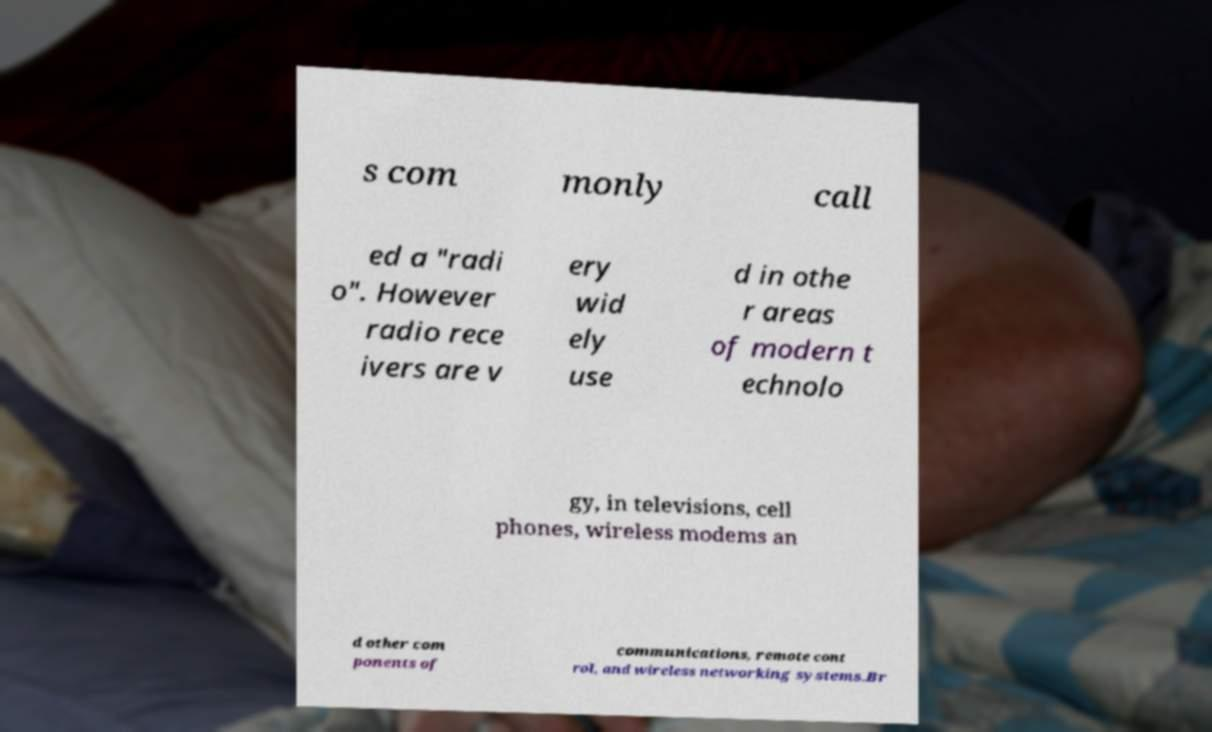Could you assist in decoding the text presented in this image and type it out clearly? s com monly call ed a "radi o". However radio rece ivers are v ery wid ely use d in othe r areas of modern t echnolo gy, in televisions, cell phones, wireless modems an d other com ponents of communications, remote cont rol, and wireless networking systems.Br 